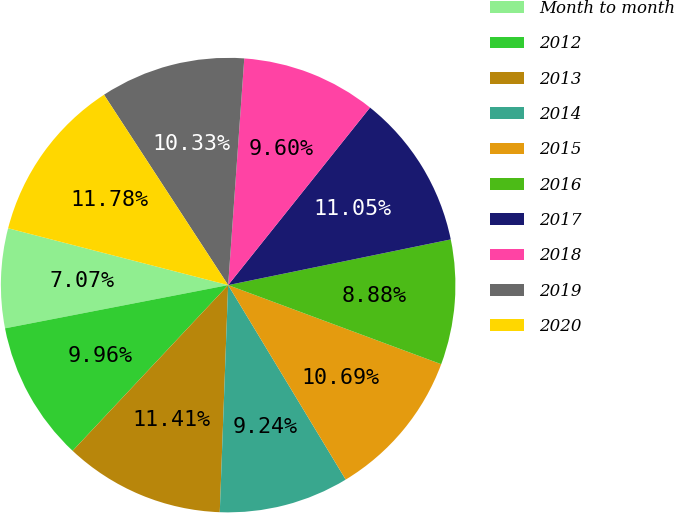Convert chart to OTSL. <chart><loc_0><loc_0><loc_500><loc_500><pie_chart><fcel>Month to month<fcel>2012<fcel>2013<fcel>2014<fcel>2015<fcel>2016<fcel>2017<fcel>2018<fcel>2019<fcel>2020<nl><fcel>7.07%<fcel>9.96%<fcel>11.41%<fcel>9.24%<fcel>10.69%<fcel>8.88%<fcel>11.05%<fcel>9.6%<fcel>10.33%<fcel>11.78%<nl></chart> 